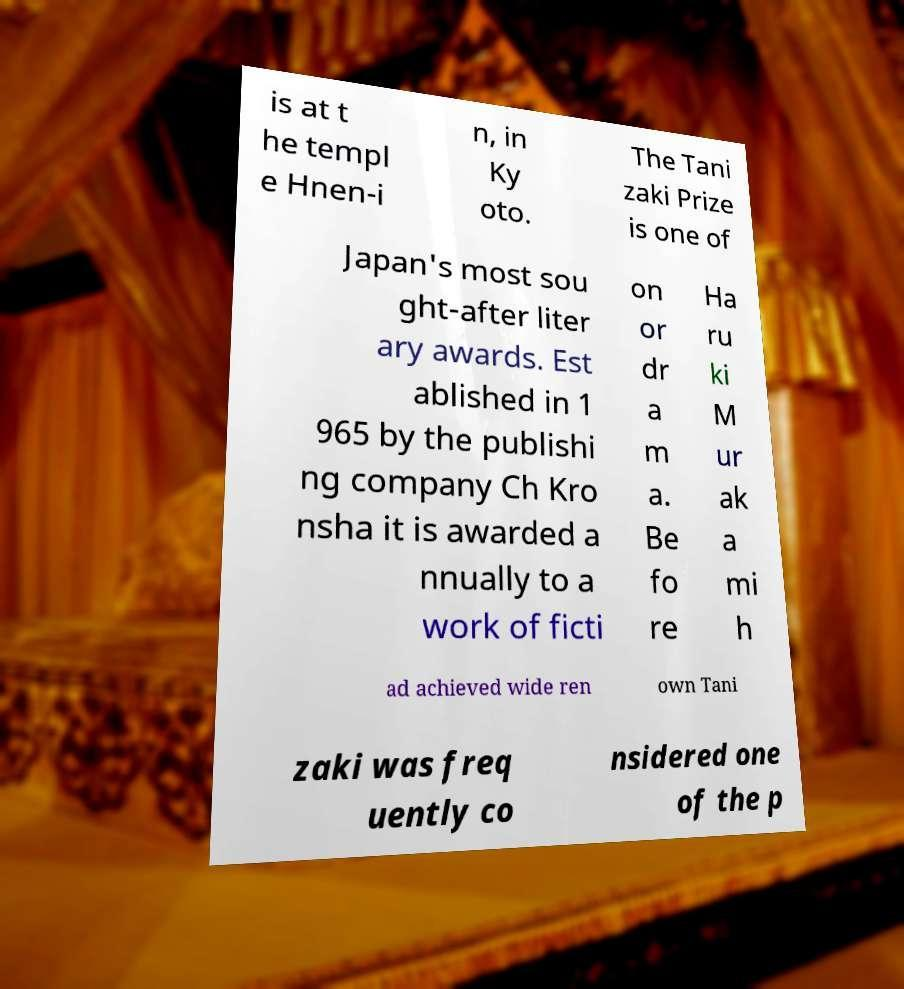Can you accurately transcribe the text from the provided image for me? is at t he templ e Hnen-i n, in Ky oto. The Tani zaki Prize is one of Japan's most sou ght-after liter ary awards. Est ablished in 1 965 by the publishi ng company Ch Kro nsha it is awarded a nnually to a work of ficti on or dr a m a. Be fo re Ha ru ki M ur ak a mi h ad achieved wide ren own Tani zaki was freq uently co nsidered one of the p 